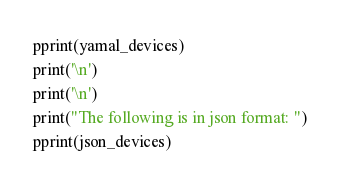Convert code to text. <code><loc_0><loc_0><loc_500><loc_500><_Python_>pprint(yamal_devices)
print('\n')
print('\n')
print("The following is in json format: ")
pprint(json_devices)
</code> 